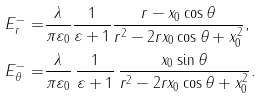Convert formula to latex. <formula><loc_0><loc_0><loc_500><loc_500>E _ { r } ^ { - } = & \frac { \lambda } { \pi \varepsilon _ { 0 } } \frac { 1 } { \varepsilon + 1 } \frac { r - x _ { 0 } \cos \theta } { r ^ { 2 } - 2 r x _ { 0 } \cos \theta + x _ { 0 } ^ { 2 } } , \\ E _ { \theta } ^ { - } = & \frac { \lambda } { \pi \varepsilon _ { 0 } } \, \frac { 1 } { \varepsilon + 1 } \, \frac { x _ { 0 } \sin \theta } { r ^ { 2 } - 2 r x _ { 0 } \cos \theta + x _ { 0 } ^ { 2 } } .</formula> 